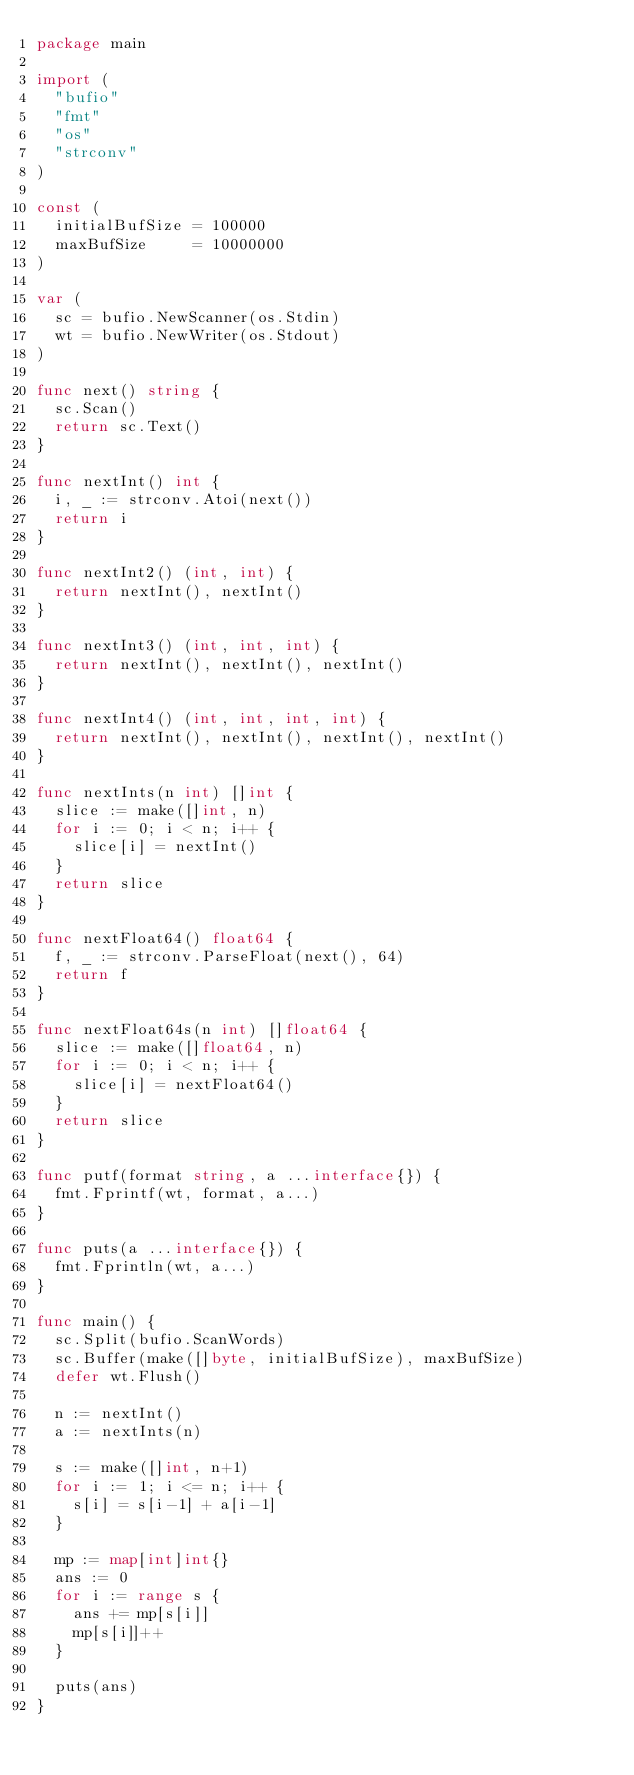<code> <loc_0><loc_0><loc_500><loc_500><_Go_>package main

import (
	"bufio"
	"fmt"
	"os"
	"strconv"
)

const (
	initialBufSize = 100000
	maxBufSize     = 10000000
)

var (
	sc = bufio.NewScanner(os.Stdin)
	wt = bufio.NewWriter(os.Stdout)
)

func next() string {
	sc.Scan()
	return sc.Text()
}

func nextInt() int {
	i, _ := strconv.Atoi(next())
	return i
}

func nextInt2() (int, int) {
	return nextInt(), nextInt()
}

func nextInt3() (int, int, int) {
	return nextInt(), nextInt(), nextInt()
}

func nextInt4() (int, int, int, int) {
	return nextInt(), nextInt(), nextInt(), nextInt()
}

func nextInts(n int) []int {
	slice := make([]int, n)
	for i := 0; i < n; i++ {
		slice[i] = nextInt()
	}
	return slice
}

func nextFloat64() float64 {
	f, _ := strconv.ParseFloat(next(), 64)
	return f
}

func nextFloat64s(n int) []float64 {
	slice := make([]float64, n)
	for i := 0; i < n; i++ {
		slice[i] = nextFloat64()
	}
	return slice
}

func putf(format string, a ...interface{}) {
	fmt.Fprintf(wt, format, a...)
}

func puts(a ...interface{}) {
	fmt.Fprintln(wt, a...)
}

func main() {
	sc.Split(bufio.ScanWords)
	sc.Buffer(make([]byte, initialBufSize), maxBufSize)
	defer wt.Flush()

	n := nextInt()
	a := nextInts(n)

	s := make([]int, n+1)
	for i := 1; i <= n; i++ {
		s[i] = s[i-1] + a[i-1]
	}

	mp := map[int]int{}
	ans := 0
	for i := range s {
		ans += mp[s[i]]
		mp[s[i]]++
	}

	puts(ans)
}
</code> 